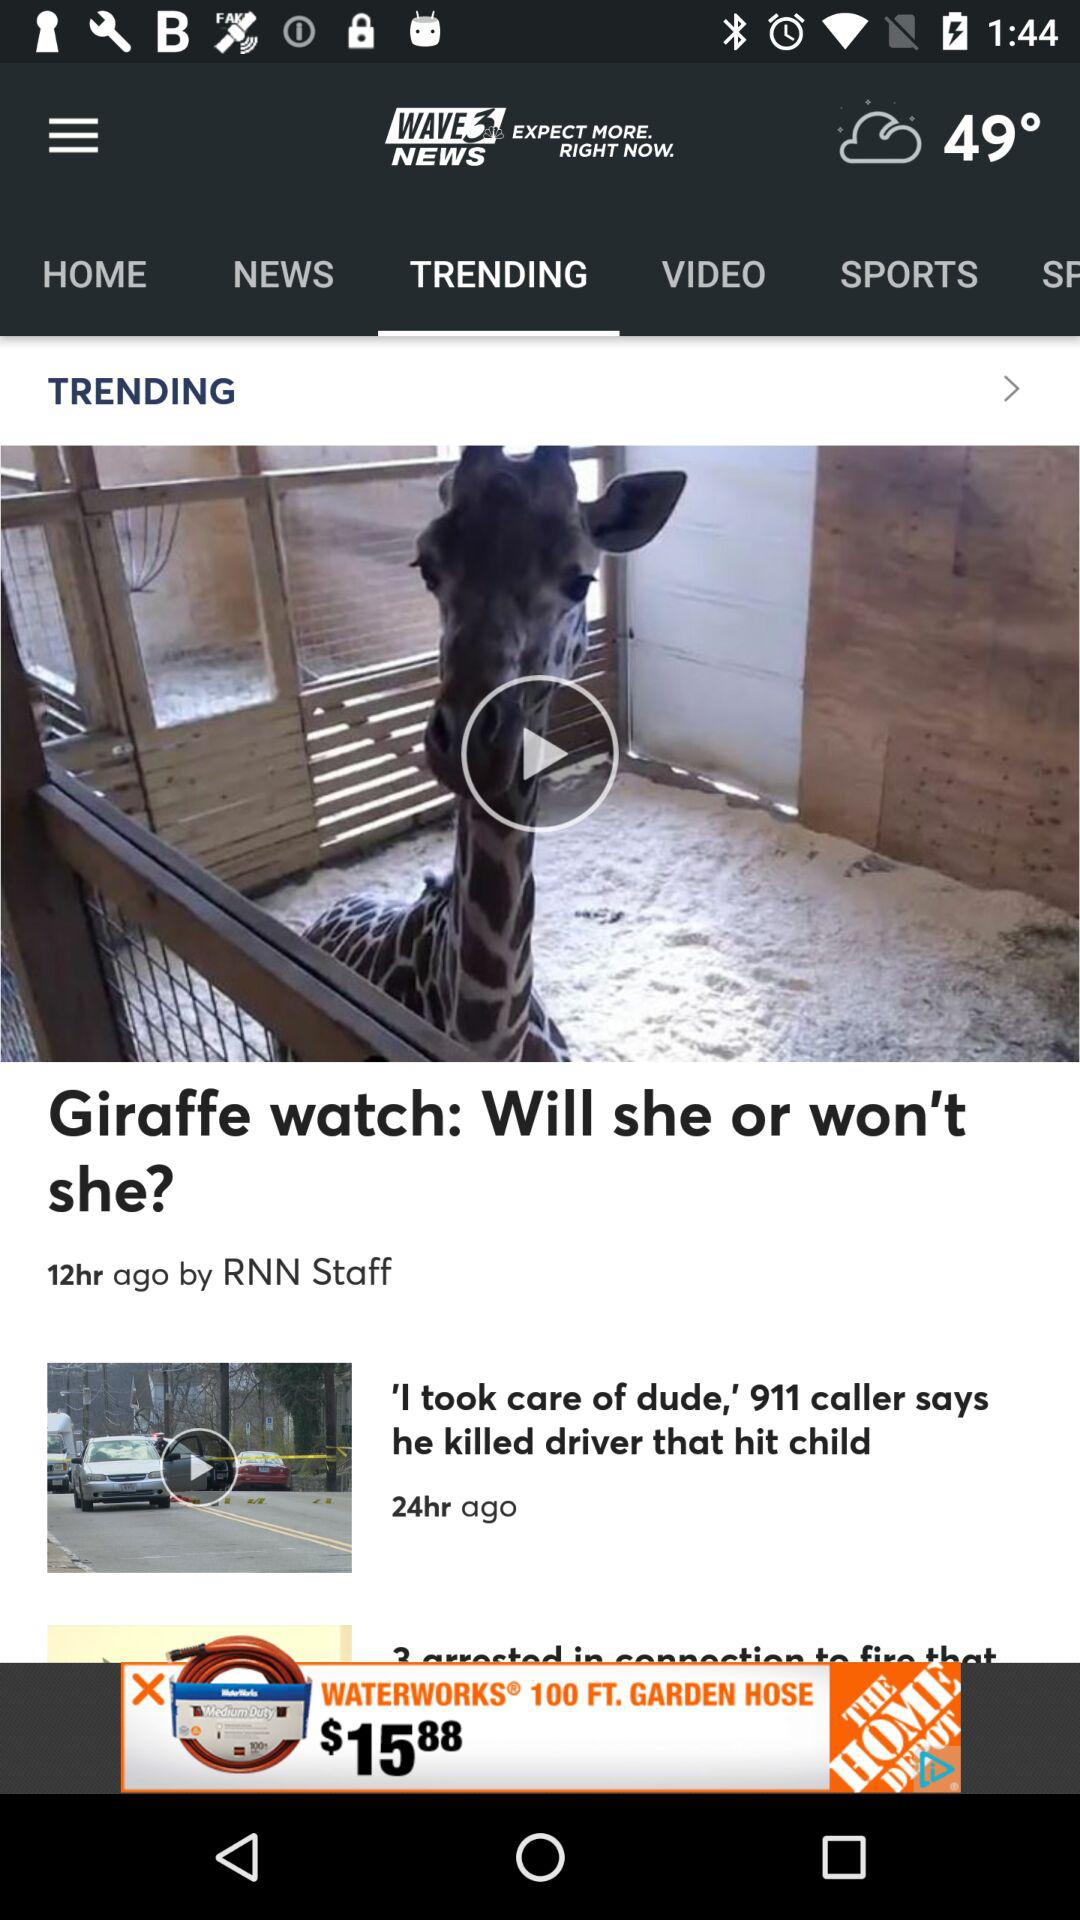Who posted the "Giraffe watch" video? The "Giraffe watch" video was posted by RNN Staff. 